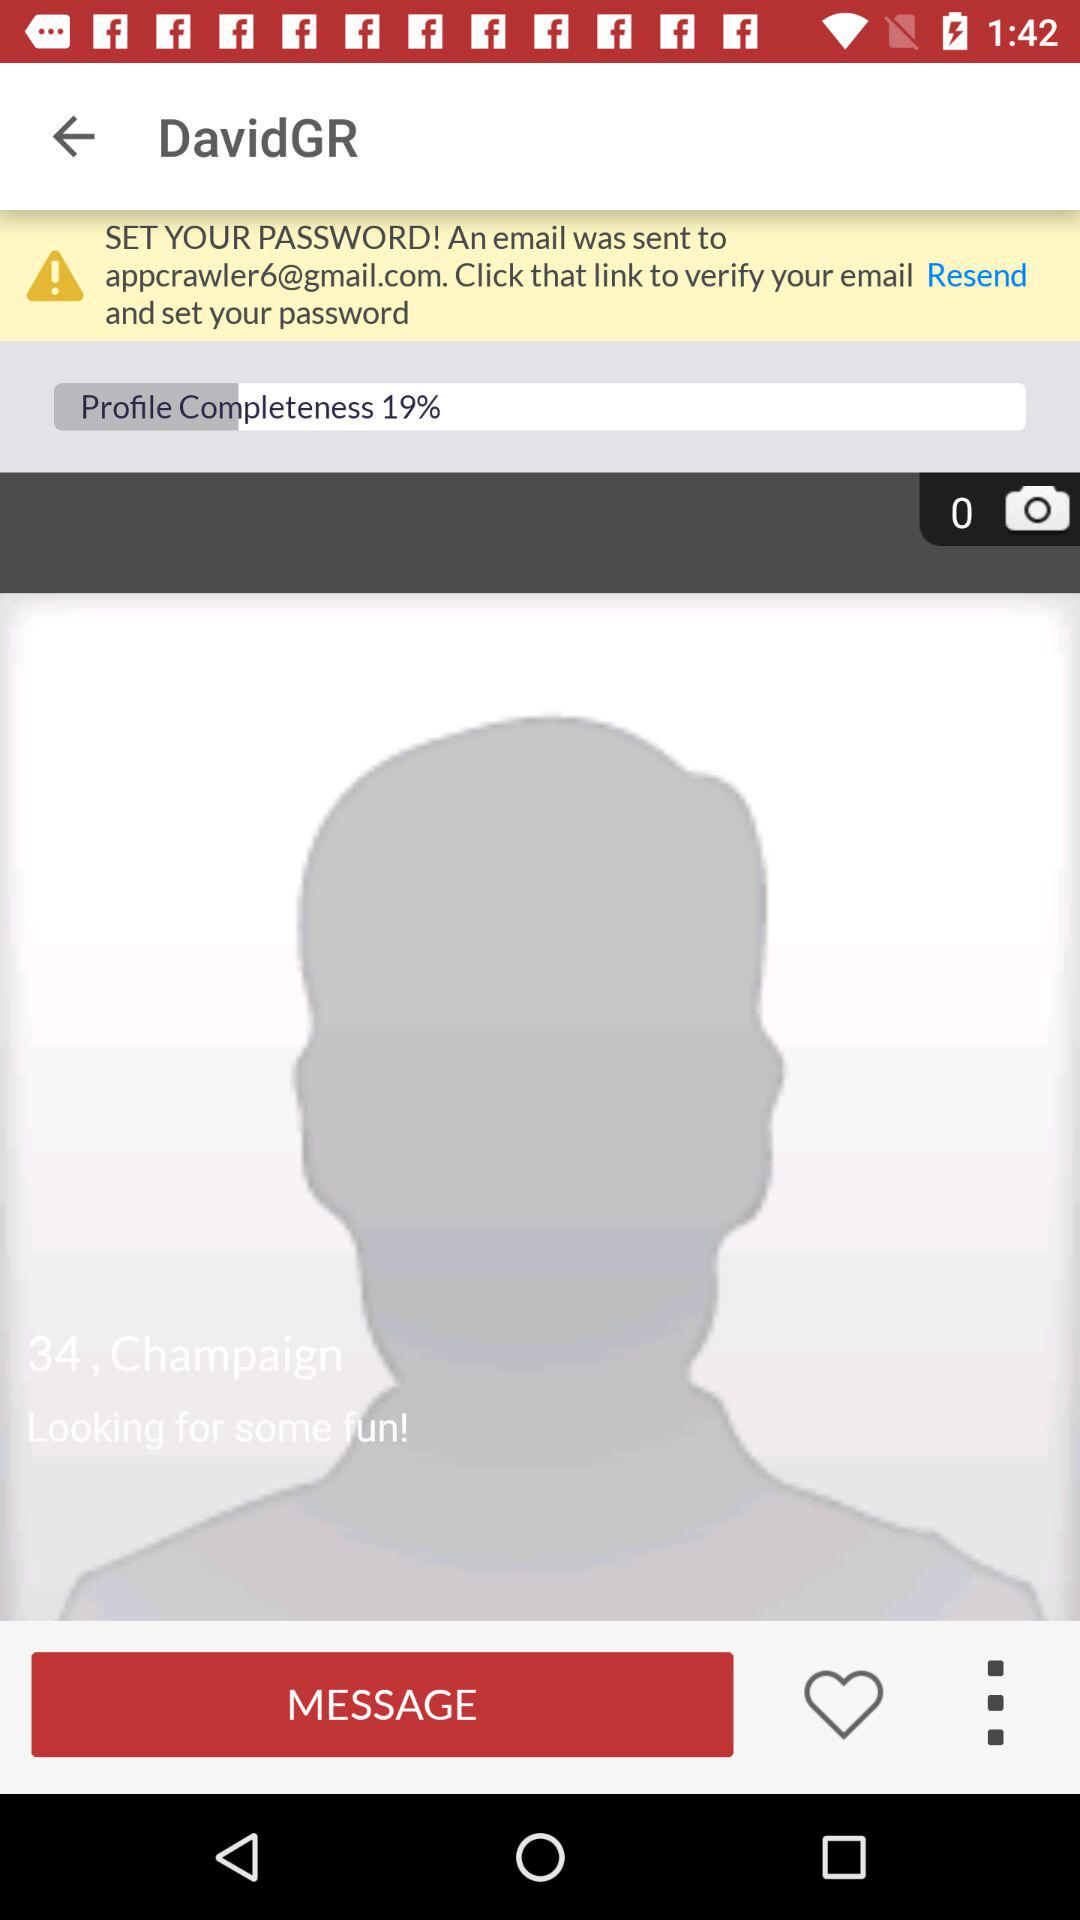How many images in total are there? There are 0 images. 